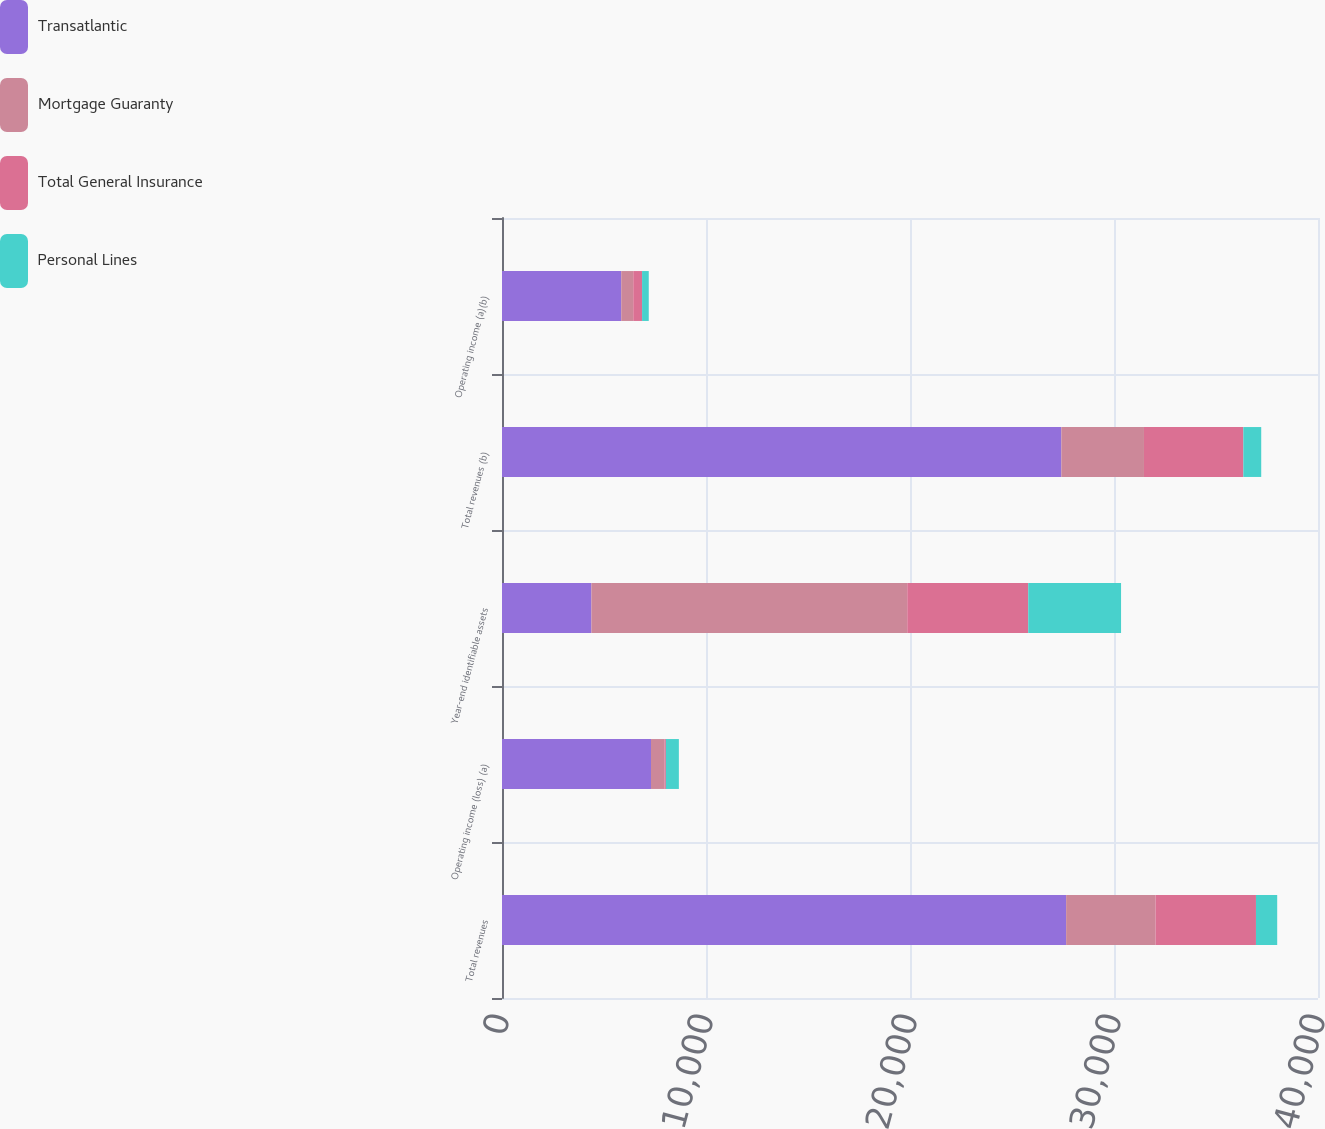Convert chart. <chart><loc_0><loc_0><loc_500><loc_500><stacked_bar_chart><ecel><fcel>Total revenues<fcel>Operating income (loss) (a)<fcel>Year-end identifiable assets<fcel>Total revenues (b)<fcel>Operating income (a)(b)<nl><fcel>Transatlantic<fcel>27653<fcel>7305<fcel>4382<fcel>27419<fcel>5845<nl><fcel>Mortgage Guaranty<fcel>4382<fcel>661<fcel>15484<fcel>4050<fcel>589<nl><fcel>Total General Insurance<fcel>4924<fcel>67<fcel>5930<fcel>4871<fcel>432<nl><fcel>Personal Lines<fcel>1041<fcel>637<fcel>4550<fcel>877<fcel>328<nl></chart> 